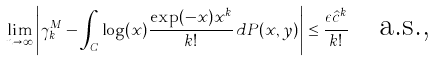<formula> <loc_0><loc_0><loc_500><loc_500>\lim _ { n \rightarrow \infty } \left | \gamma _ { k } ^ { M } - \int _ { C } \log ( x ) \frac { \exp ( - x ) x ^ { k } } { k ! } \, d P ( x , y ) \right | \leq \frac { \epsilon \hat { c } ^ { k } } { k ! } \quad \text {a.s.,}</formula> 